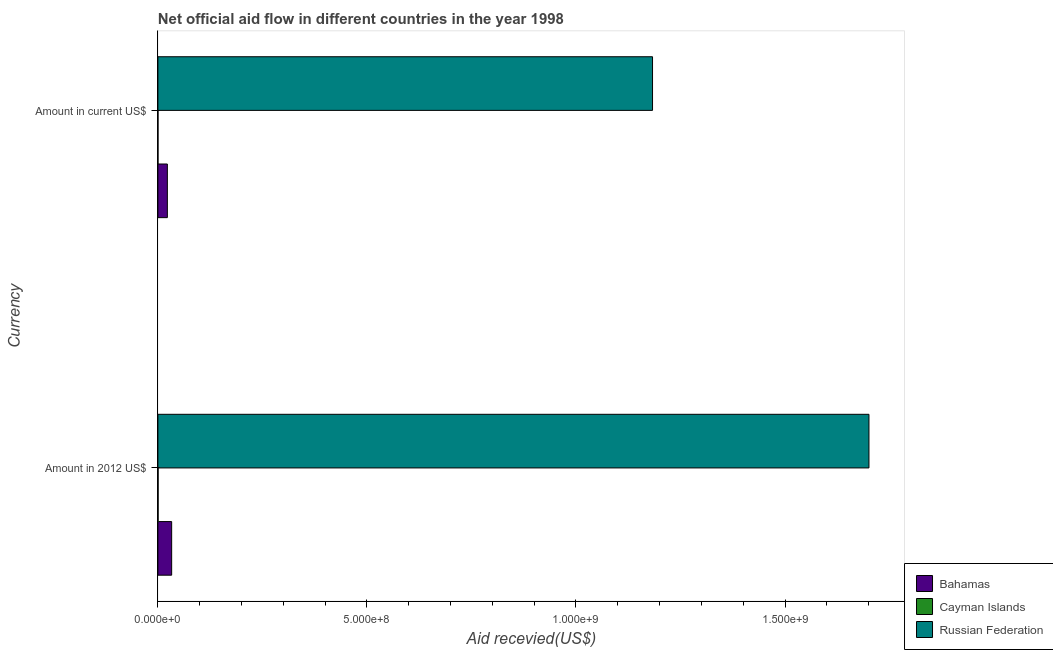How many different coloured bars are there?
Your answer should be compact. 3. How many groups of bars are there?
Your answer should be compact. 2. Are the number of bars per tick equal to the number of legend labels?
Keep it short and to the point. Yes. Are the number of bars on each tick of the Y-axis equal?
Offer a terse response. Yes. How many bars are there on the 2nd tick from the bottom?
Your response must be concise. 3. What is the label of the 1st group of bars from the top?
Your answer should be compact. Amount in current US$. What is the amount of aid received(expressed in 2012 us$) in Russian Federation?
Provide a succinct answer. 1.70e+09. Across all countries, what is the maximum amount of aid received(expressed in us$)?
Offer a very short reply. 1.18e+09. Across all countries, what is the minimum amount of aid received(expressed in us$)?
Give a very brief answer. 1.60e+05. In which country was the amount of aid received(expressed in 2012 us$) maximum?
Offer a terse response. Russian Federation. In which country was the amount of aid received(expressed in us$) minimum?
Keep it short and to the point. Cayman Islands. What is the total amount of aid received(expressed in 2012 us$) in the graph?
Give a very brief answer. 1.73e+09. What is the difference between the amount of aid received(expressed in us$) in Cayman Islands and that in Russian Federation?
Your answer should be compact. -1.18e+09. What is the difference between the amount of aid received(expressed in 2012 us$) in Cayman Islands and the amount of aid received(expressed in us$) in Russian Federation?
Your response must be concise. -1.18e+09. What is the average amount of aid received(expressed in us$) per country?
Your answer should be compact. 4.02e+08. What is the difference between the amount of aid received(expressed in us$) and amount of aid received(expressed in 2012 us$) in Cayman Islands?
Give a very brief answer. -2.90e+05. What is the ratio of the amount of aid received(expressed in us$) in Russian Federation to that in Bahamas?
Provide a short and direct response. 52.33. Is the amount of aid received(expressed in us$) in Bahamas less than that in Cayman Islands?
Keep it short and to the point. No. In how many countries, is the amount of aid received(expressed in us$) greater than the average amount of aid received(expressed in us$) taken over all countries?
Offer a very short reply. 1. What does the 3rd bar from the top in Amount in 2012 US$ represents?
Keep it short and to the point. Bahamas. What does the 3rd bar from the bottom in Amount in 2012 US$ represents?
Offer a very short reply. Russian Federation. How many bars are there?
Offer a terse response. 6. Are all the bars in the graph horizontal?
Ensure brevity in your answer.  Yes. What is the difference between two consecutive major ticks on the X-axis?
Ensure brevity in your answer.  5.00e+08. Are the values on the major ticks of X-axis written in scientific E-notation?
Provide a short and direct response. Yes. How many legend labels are there?
Ensure brevity in your answer.  3. How are the legend labels stacked?
Keep it short and to the point. Vertical. What is the title of the graph?
Keep it short and to the point. Net official aid flow in different countries in the year 1998. What is the label or title of the X-axis?
Offer a terse response. Aid recevied(US$). What is the label or title of the Y-axis?
Your answer should be compact. Currency. What is the Aid recevied(US$) in Bahamas in Amount in 2012 US$?
Provide a short and direct response. 3.29e+07. What is the Aid recevied(US$) of Russian Federation in Amount in 2012 US$?
Offer a very short reply. 1.70e+09. What is the Aid recevied(US$) in Bahamas in Amount in current US$?
Make the answer very short. 2.26e+07. What is the Aid recevied(US$) in Russian Federation in Amount in current US$?
Your answer should be compact. 1.18e+09. Across all Currency, what is the maximum Aid recevied(US$) of Bahamas?
Your answer should be compact. 3.29e+07. Across all Currency, what is the maximum Aid recevied(US$) in Russian Federation?
Your response must be concise. 1.70e+09. Across all Currency, what is the minimum Aid recevied(US$) of Bahamas?
Give a very brief answer. 2.26e+07. Across all Currency, what is the minimum Aid recevied(US$) in Russian Federation?
Keep it short and to the point. 1.18e+09. What is the total Aid recevied(US$) in Bahamas in the graph?
Your answer should be very brief. 5.55e+07. What is the total Aid recevied(US$) in Cayman Islands in the graph?
Ensure brevity in your answer.  6.10e+05. What is the total Aid recevied(US$) of Russian Federation in the graph?
Offer a terse response. 2.88e+09. What is the difference between the Aid recevied(US$) of Bahamas in Amount in 2012 US$ and that in Amount in current US$?
Provide a short and direct response. 1.03e+07. What is the difference between the Aid recevied(US$) of Russian Federation in Amount in 2012 US$ and that in Amount in current US$?
Offer a very short reply. 5.18e+08. What is the difference between the Aid recevied(US$) of Bahamas in Amount in 2012 US$ and the Aid recevied(US$) of Cayman Islands in Amount in current US$?
Your answer should be very brief. 3.27e+07. What is the difference between the Aid recevied(US$) of Bahamas in Amount in 2012 US$ and the Aid recevied(US$) of Russian Federation in Amount in current US$?
Offer a very short reply. -1.15e+09. What is the difference between the Aid recevied(US$) in Cayman Islands in Amount in 2012 US$ and the Aid recevied(US$) in Russian Federation in Amount in current US$?
Give a very brief answer. -1.18e+09. What is the average Aid recevied(US$) of Bahamas per Currency?
Keep it short and to the point. 2.78e+07. What is the average Aid recevied(US$) of Cayman Islands per Currency?
Your answer should be very brief. 3.05e+05. What is the average Aid recevied(US$) in Russian Federation per Currency?
Ensure brevity in your answer.  1.44e+09. What is the difference between the Aid recevied(US$) of Bahamas and Aid recevied(US$) of Cayman Islands in Amount in 2012 US$?
Ensure brevity in your answer.  3.24e+07. What is the difference between the Aid recevied(US$) in Bahamas and Aid recevied(US$) in Russian Federation in Amount in 2012 US$?
Ensure brevity in your answer.  -1.67e+09. What is the difference between the Aid recevied(US$) of Cayman Islands and Aid recevied(US$) of Russian Federation in Amount in 2012 US$?
Offer a very short reply. -1.70e+09. What is the difference between the Aid recevied(US$) of Bahamas and Aid recevied(US$) of Cayman Islands in Amount in current US$?
Offer a very short reply. 2.24e+07. What is the difference between the Aid recevied(US$) in Bahamas and Aid recevied(US$) in Russian Federation in Amount in current US$?
Ensure brevity in your answer.  -1.16e+09. What is the difference between the Aid recevied(US$) in Cayman Islands and Aid recevied(US$) in Russian Federation in Amount in current US$?
Your answer should be very brief. -1.18e+09. What is the ratio of the Aid recevied(US$) of Bahamas in Amount in 2012 US$ to that in Amount in current US$?
Make the answer very short. 1.46. What is the ratio of the Aid recevied(US$) in Cayman Islands in Amount in 2012 US$ to that in Amount in current US$?
Keep it short and to the point. 2.81. What is the ratio of the Aid recevied(US$) of Russian Federation in Amount in 2012 US$ to that in Amount in current US$?
Offer a terse response. 1.44. What is the difference between the highest and the second highest Aid recevied(US$) in Bahamas?
Keep it short and to the point. 1.03e+07. What is the difference between the highest and the second highest Aid recevied(US$) of Cayman Islands?
Offer a very short reply. 2.90e+05. What is the difference between the highest and the second highest Aid recevied(US$) of Russian Federation?
Make the answer very short. 5.18e+08. What is the difference between the highest and the lowest Aid recevied(US$) of Bahamas?
Your answer should be compact. 1.03e+07. What is the difference between the highest and the lowest Aid recevied(US$) in Cayman Islands?
Offer a terse response. 2.90e+05. What is the difference between the highest and the lowest Aid recevied(US$) in Russian Federation?
Make the answer very short. 5.18e+08. 